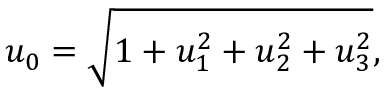Convert formula to latex. <formula><loc_0><loc_0><loc_500><loc_500>u _ { 0 } = \sqrt { 1 + u _ { 1 } ^ { 2 } + u _ { 2 } ^ { 2 } + u _ { 3 } ^ { 2 } } ,</formula> 